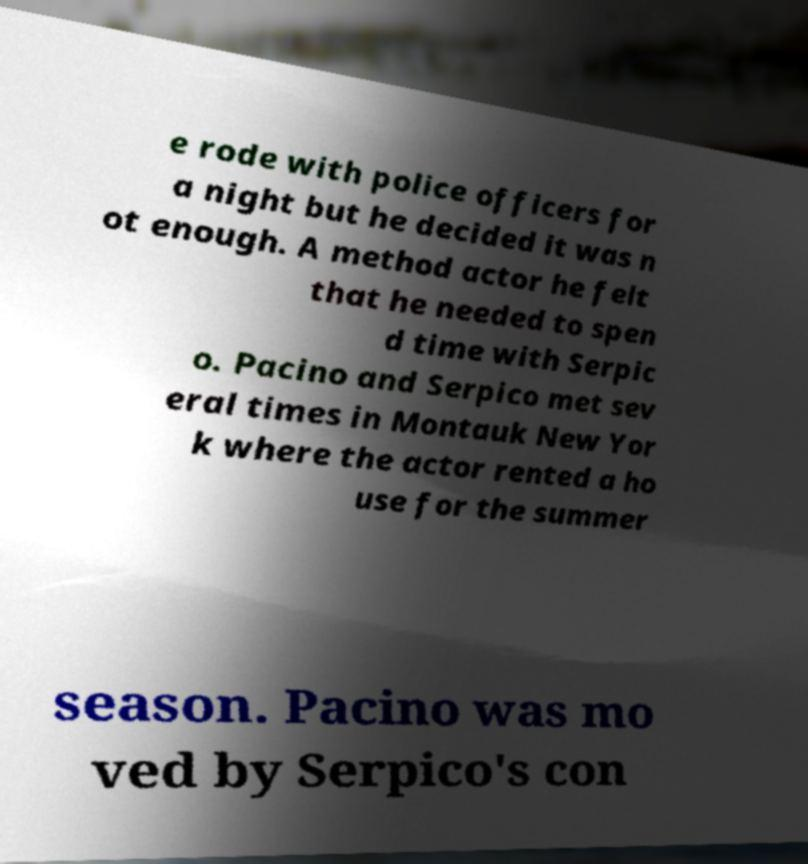Could you extract and type out the text from this image? e rode with police officers for a night but he decided it was n ot enough. A method actor he felt that he needed to spen d time with Serpic o. Pacino and Serpico met sev eral times in Montauk New Yor k where the actor rented a ho use for the summer season. Pacino was mo ved by Serpico's con 